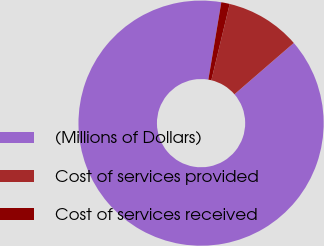Convert chart. <chart><loc_0><loc_0><loc_500><loc_500><pie_chart><fcel>(Millions of Dollars)<fcel>Cost of services provided<fcel>Cost of services received<nl><fcel>88.99%<fcel>9.9%<fcel>1.11%<nl></chart> 